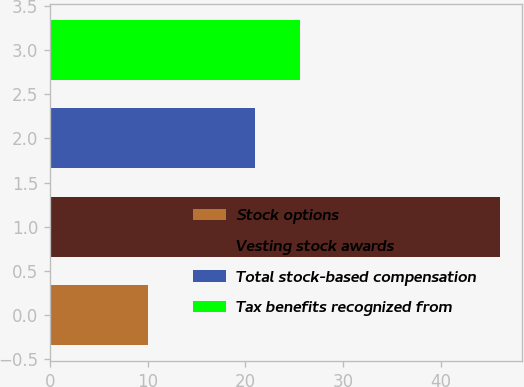Convert chart to OTSL. <chart><loc_0><loc_0><loc_500><loc_500><bar_chart><fcel>Stock options<fcel>Vesting stock awards<fcel>Total stock-based compensation<fcel>Tax benefits recognized from<nl><fcel>10<fcel>46<fcel>21<fcel>25.6<nl></chart> 